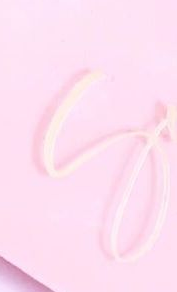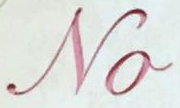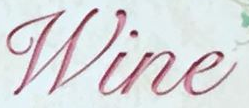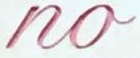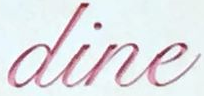Read the text content from these images in order, separated by a semicolon. S; No; Wine; no; dine 